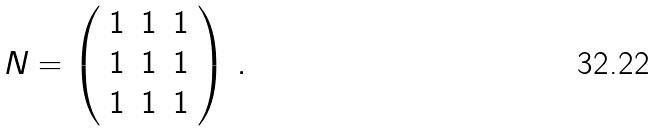Convert formula to latex. <formula><loc_0><loc_0><loc_500><loc_500>N = \left ( \begin{array} { c c c } 1 & 1 & 1 \\ 1 & 1 & 1 \\ 1 & 1 & 1 \end{array} \right ) \, .</formula> 